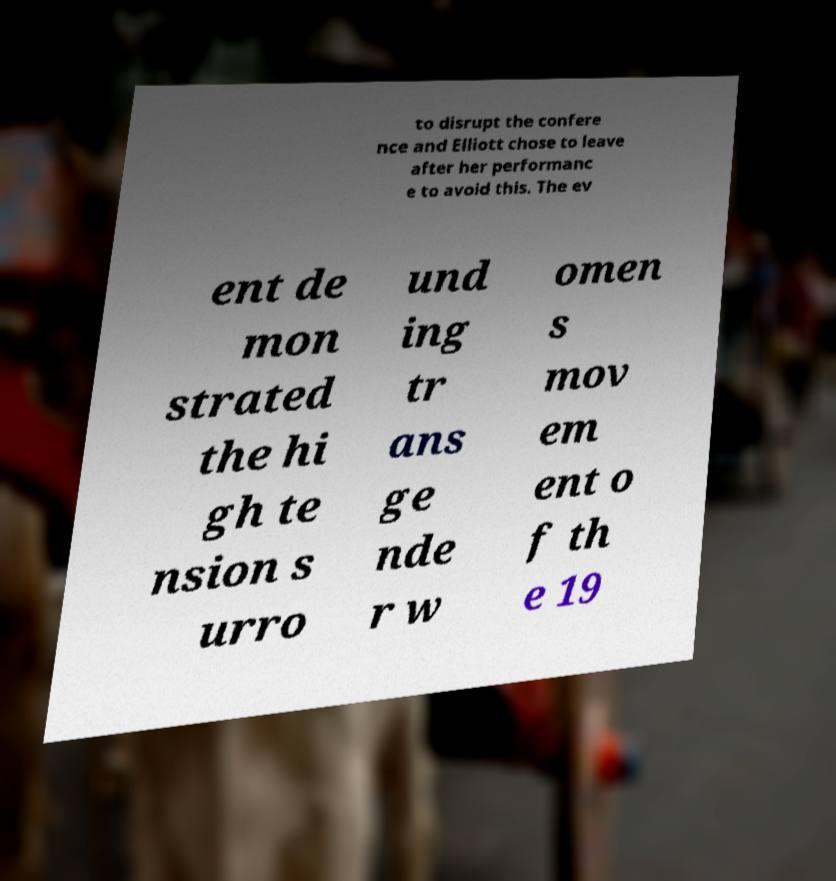Can you read and provide the text displayed in the image?This photo seems to have some interesting text. Can you extract and type it out for me? to disrupt the confere nce and Elliott chose to leave after her performanc e to avoid this. The ev ent de mon strated the hi gh te nsion s urro und ing tr ans ge nde r w omen s mov em ent o f th e 19 